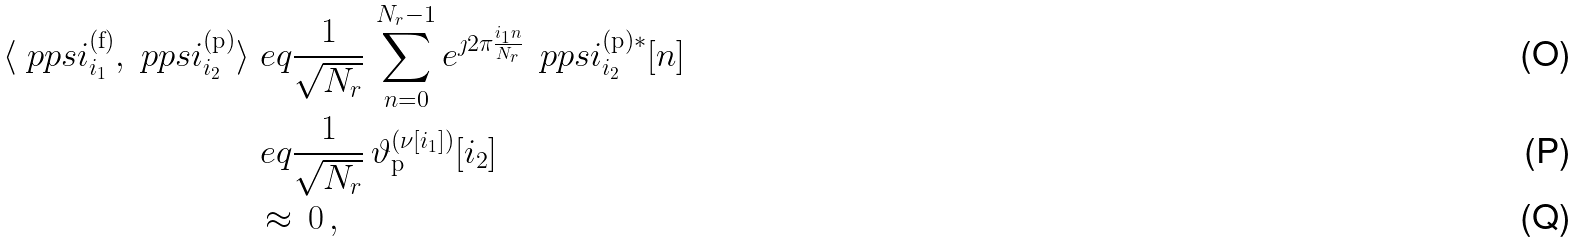Convert formula to latex. <formula><loc_0><loc_0><loc_500><loc_500>\langle \ p p s i ^ { ( \text {f} ) } _ { i _ { 1 } } , \ p p s i ^ { ( \text {p} ) } _ { i _ { 2 } } \rangle & \ e q \frac { 1 } { \sqrt { N _ { r } } } \, \sum _ { n = 0 } ^ { N _ { r } - 1 } e ^ { \jmath 2 \pi \frac { i _ { 1 } n } { N _ { r } } } \, \ p p s i ^ { ( \text {p} ) * } _ { i _ { 2 } } [ n ] \\ & \ e q \frac { 1 } { \sqrt { N _ { r } } } \, \vartheta ^ { ( \nu [ i _ { 1 } ] ) } _ { \text {p} } [ i _ { 2 } ] \\ & \, \approx \, 0 \, ,</formula> 